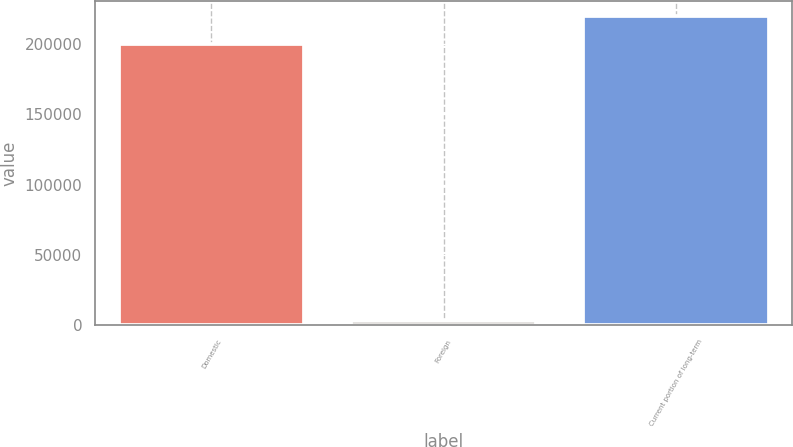Convert chart to OTSL. <chart><loc_0><loc_0><loc_500><loc_500><bar_chart><fcel>Domestic<fcel>Foreign<fcel>Current portion of long-term<nl><fcel>200000<fcel>2880<fcel>219720<nl></chart> 